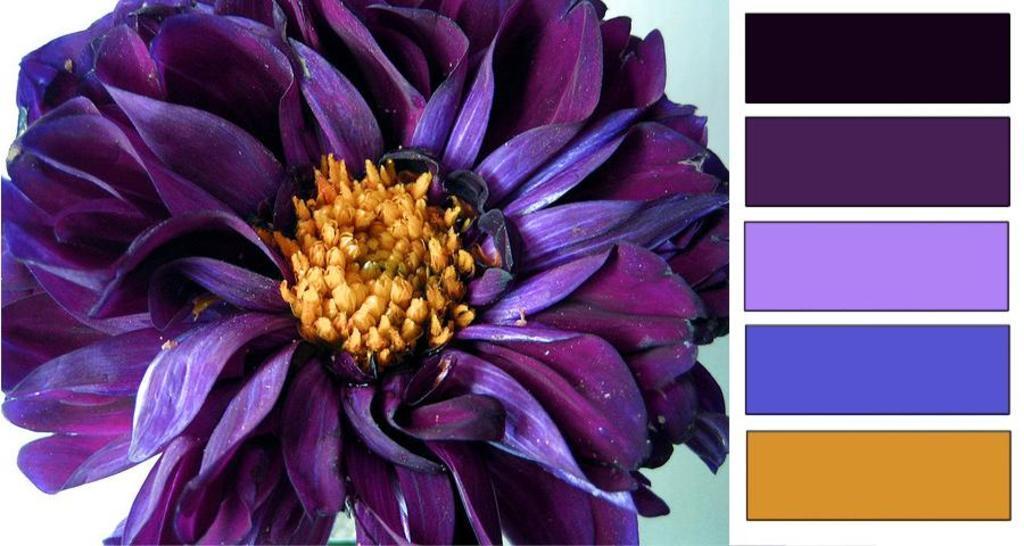How would you summarize this image in a sentence or two? In the center of the image, we can see a flower which is purple color and on the right, there are different colors. 